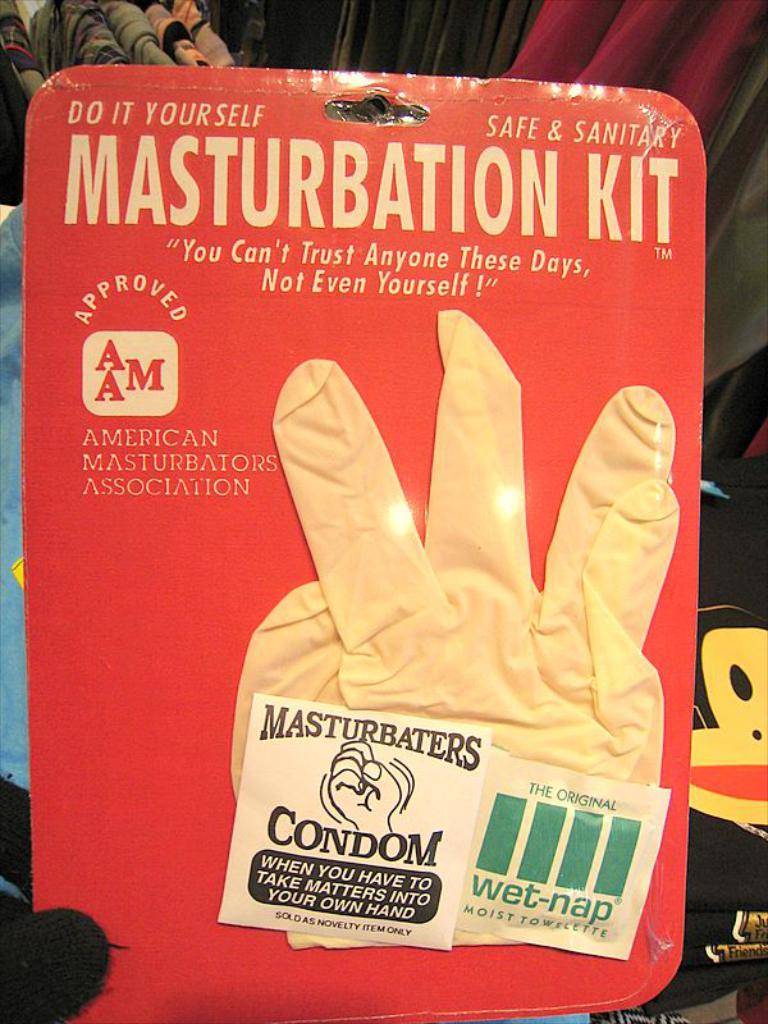What is the glove for?
Offer a terse response. Masturbation. Who can you not even trust these days?
Provide a short and direct response. Yourself. 